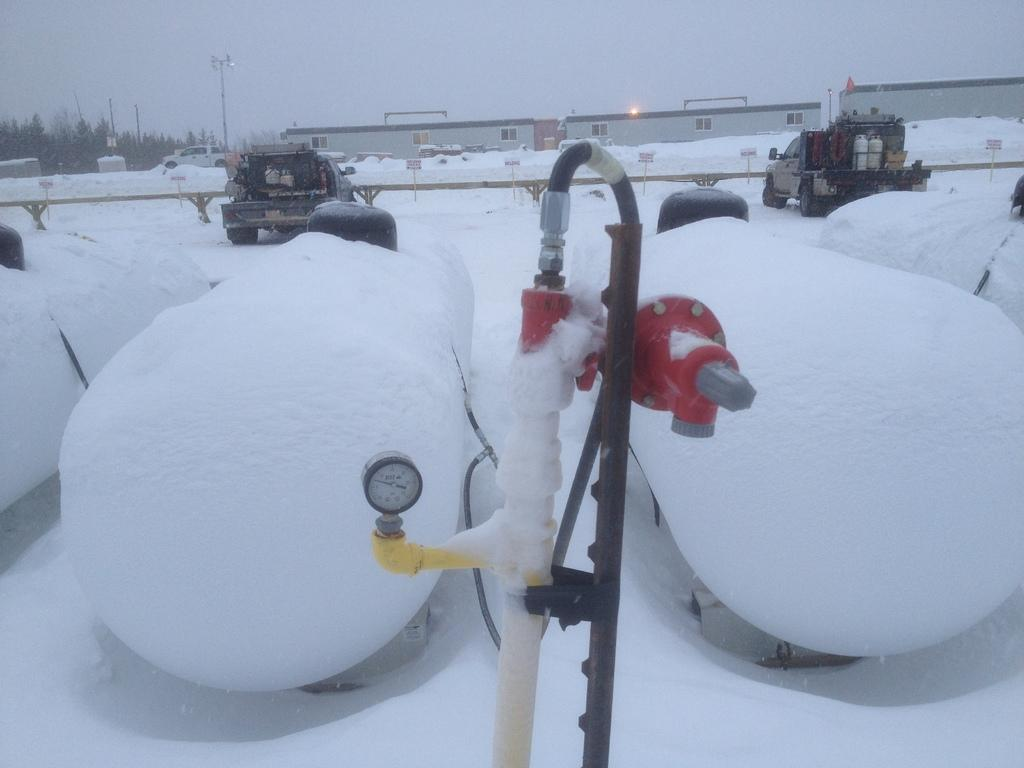What type of weather is depicted in the image? There is snow in the image, indicating a winter scene. What object is used to measure something in the image? There is a gauge in the image, which is likely used to measure temperature, pressure, or other variables. What type of infrastructure is visible in the image? Pipes, vehicles, a railing, boards, poles, and buildings are visible in the image, suggesting an industrial or urban setting. What natural elements can be seen in the image? Trees and the sky are visible in the image, along with sunlight. What role does the daughter play in the image? There is no mention of a daughter in the image, so this question cannot be answered. Which actor is performing in the image? There is no actor present in the image, so this question cannot be answered. 